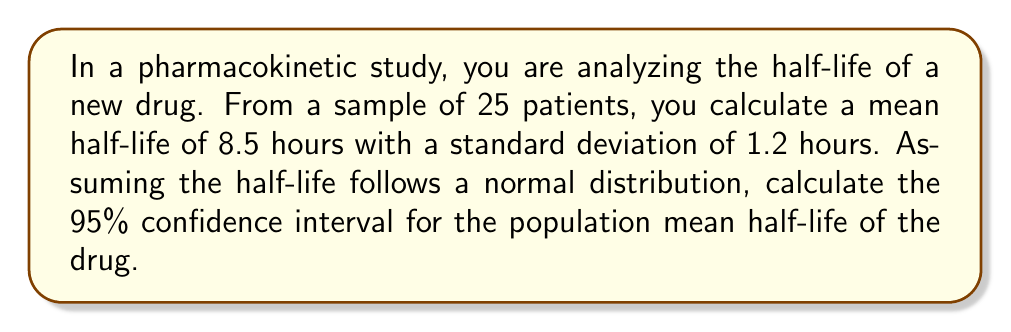Provide a solution to this math problem. To calculate the confidence interval, we'll follow these steps:

1) The formula for the confidence interval is:

   $$ \bar{x} \pm t_{\alpha/2, n-1} \cdot \frac{s}{\sqrt{n}} $$

   where $\bar{x}$ is the sample mean, $s$ is the sample standard deviation, $n$ is the sample size, and $t_{\alpha/2, n-1}$ is the t-value for a 95% confidence level with $n-1$ degrees of freedom.

2) We have:
   $\bar{x} = 8.5$ hours
   $s = 1.2$ hours
   $n = 25$
   
3) For a 95% confidence interval, $\alpha = 0.05$, and we need $t_{0.025, 24}$. From a t-table or calculator, we find:
   $t_{0.025, 24} \approx 2.064$

4) Now we can calculate the margin of error:

   $$ \text{Margin of Error} = t_{0.025, 24} \cdot \frac{s}{\sqrt{n}} = 2.064 \cdot \frac{1.2}{\sqrt{25}} \approx 0.495 $$

5) Finally, we can calculate the confidence interval:

   $$ 8.5 \pm 0.495 $$

   Lower bound: $8.5 - 0.495 = 8.005$
   Upper bound: $8.5 + 0.495 = 8.995$
Answer: (8.005, 8.995) hours 